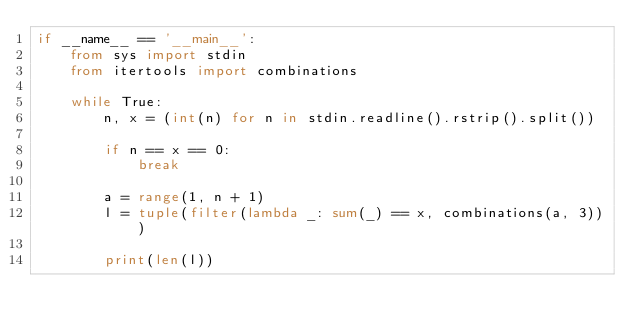<code> <loc_0><loc_0><loc_500><loc_500><_Python_>if __name__ == '__main__':
    from sys import stdin
    from itertools import combinations

    while True:
        n, x = (int(n) for n in stdin.readline().rstrip().split())

        if n == x == 0:
            break

        a = range(1, n + 1)
        l = tuple(filter(lambda _: sum(_) == x, combinations(a, 3)))

        print(len(l))
</code> 